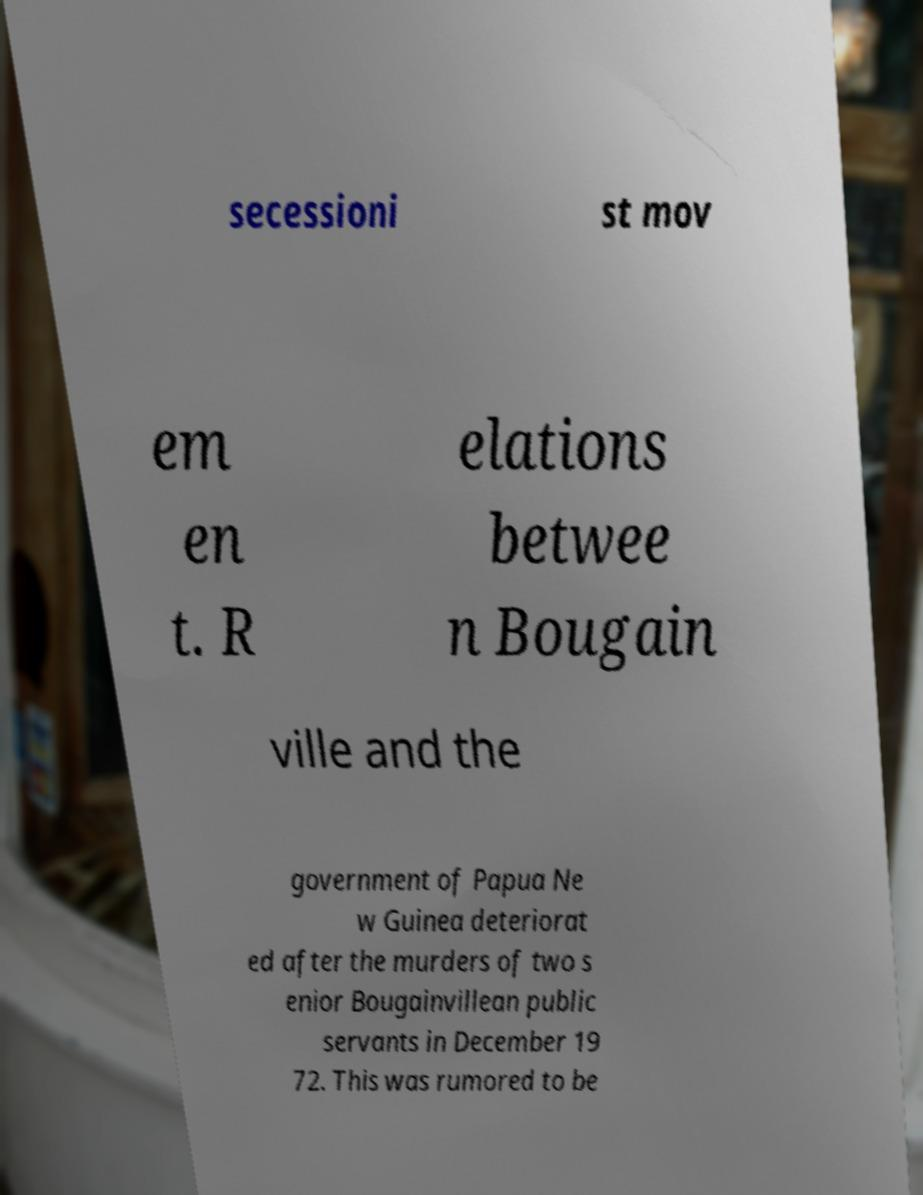What messages or text are displayed in this image? I need them in a readable, typed format. secessioni st mov em en t. R elations betwee n Bougain ville and the government of Papua Ne w Guinea deteriorat ed after the murders of two s enior Bougainvillean public servants in December 19 72. This was rumored to be 